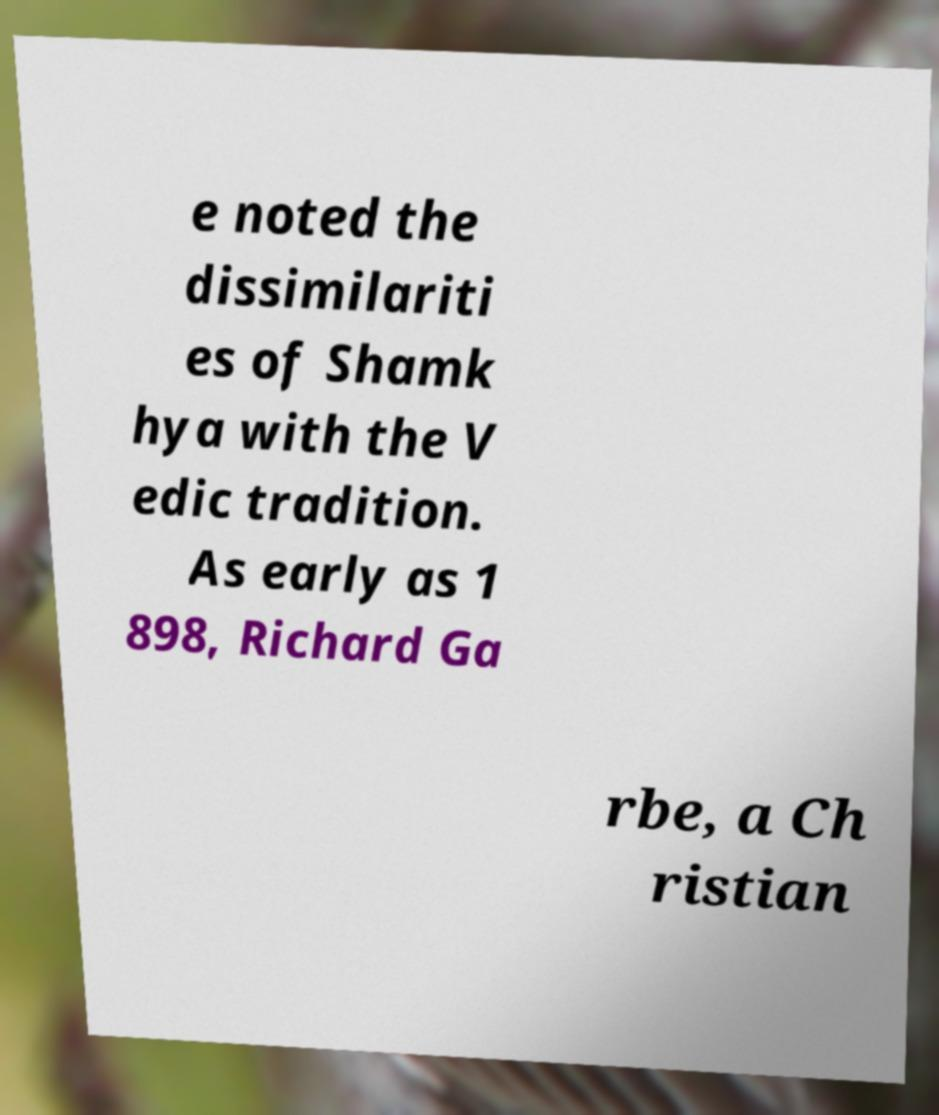There's text embedded in this image that I need extracted. Can you transcribe it verbatim? e noted the dissimilariti es of Shamk hya with the V edic tradition. As early as 1 898, Richard Ga rbe, a Ch ristian 